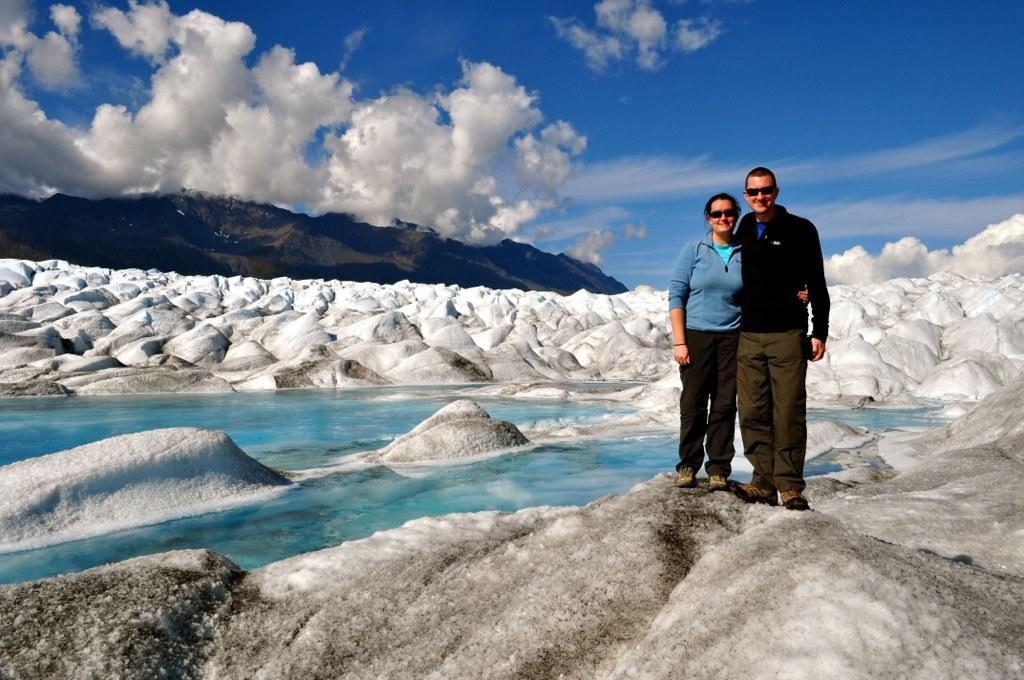Describe this image in one or two sentences. In this picture I can see a woman and a man on the right side. In the middle there is the water and the snow, in the background there are hills. at the top there is the sky. 